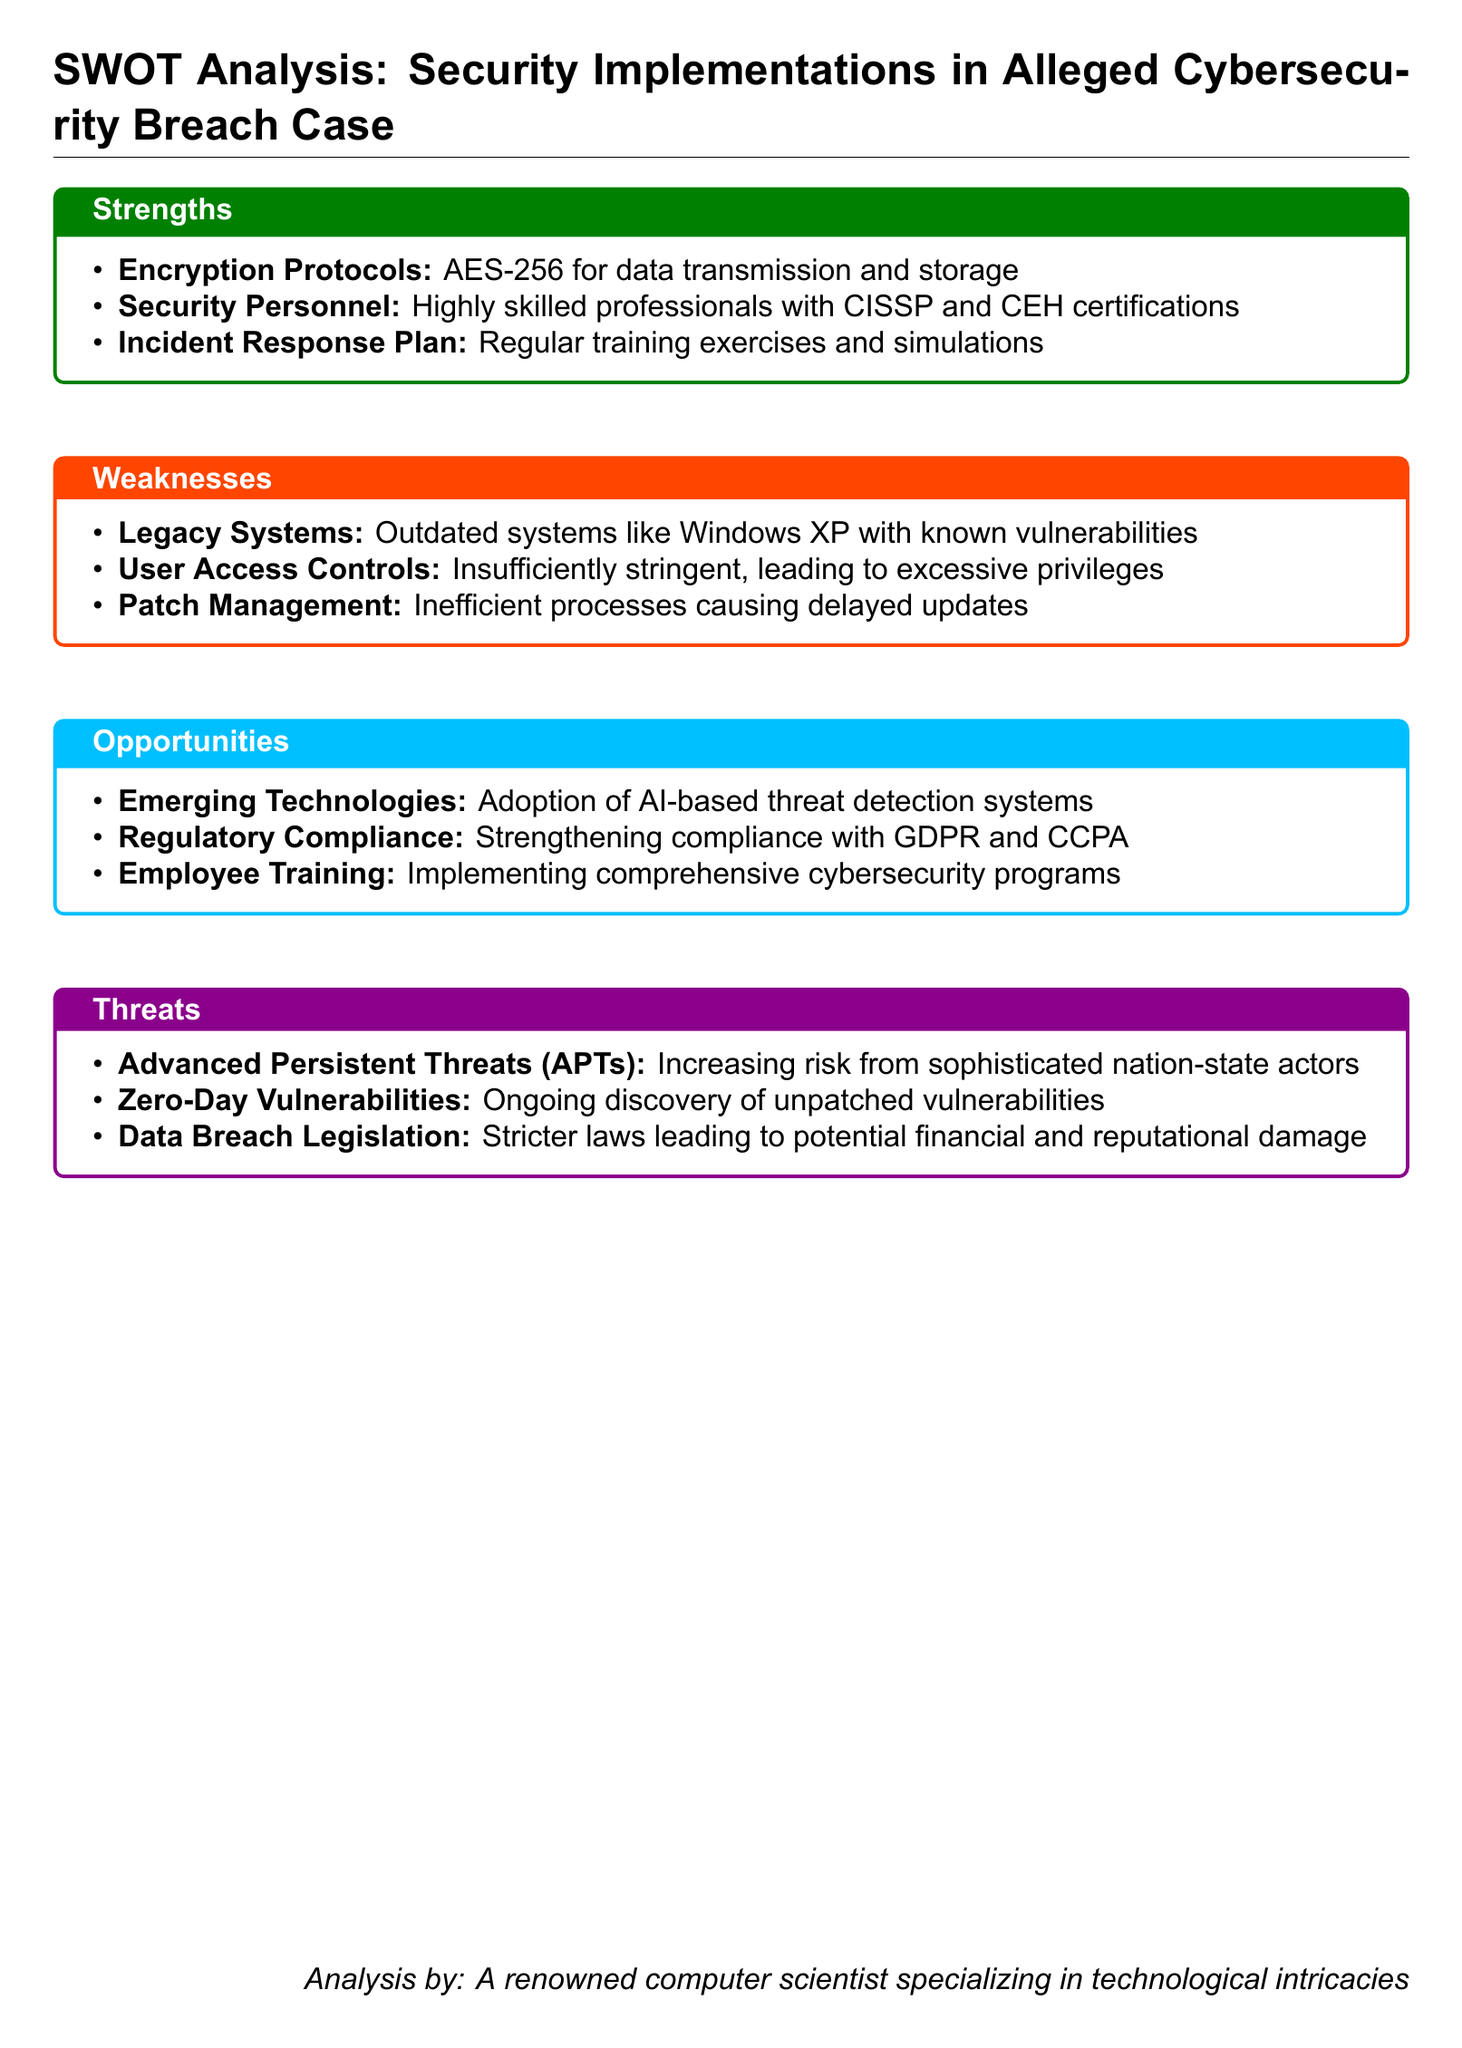what encryption protocol is used for data transmission? The document specifies that AES-256 is used for data transmission and storage.
Answer: AES-256 who are the security personnel certified by? The document mentions CISSP and CEH certifications for the security personnel.
Answer: CISSP and CEH what is a significant weakness related to outdated systems? The document highlights that outdated systems like Windows XP are known vulnerabilities.
Answer: Windows XP which opportunities involve regulatory compliance? The document states that strengthening compliance with GDPR and CCPA is an opportunity.
Answer: GDPR and CCPA what type of threat is increasing from sophisticated actors? The document indicates that the risk from Advanced Persistent Threats (APTs) is increasing.
Answer: Advanced Persistent Threats (APTs) how many strengths are listed in the document? The document lists three strengths in the SWOT analysis.
Answer: 3 what training program is mentioned as an opportunity? The document refers to the implementation of comprehensive cybersecurity programs as an opportunity.
Answer: comprehensive cybersecurity programs which factor leads to potential financial and reputational damage? The document points out that stricter data breach legislation poses this risk.
Answer: stricter data breach legislation what is an identified weakness regarding user access? The document notes that user access controls are insufficiently stringent.
Answer: insufficiently stringent 